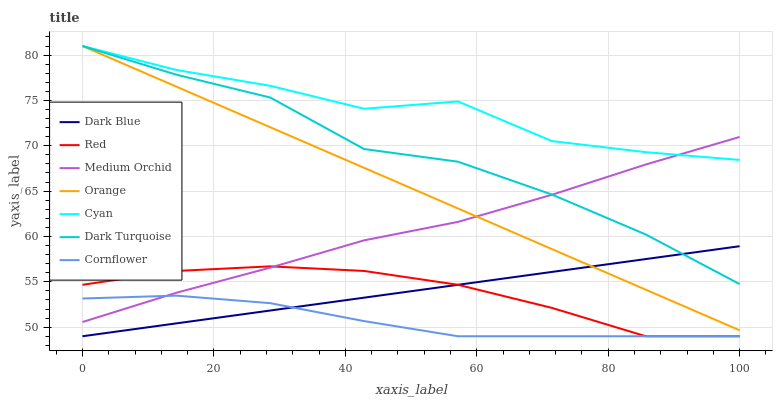Does Dark Turquoise have the minimum area under the curve?
Answer yes or no. No. Does Dark Turquoise have the maximum area under the curve?
Answer yes or no. No. Is Dark Turquoise the smoothest?
Answer yes or no. No. Is Dark Turquoise the roughest?
Answer yes or no. No. Does Dark Turquoise have the lowest value?
Answer yes or no. No. Does Medium Orchid have the highest value?
Answer yes or no. No. Is Cornflower less than Orange?
Answer yes or no. Yes. Is Cyan greater than Cornflower?
Answer yes or no. Yes. Does Cornflower intersect Orange?
Answer yes or no. No. 